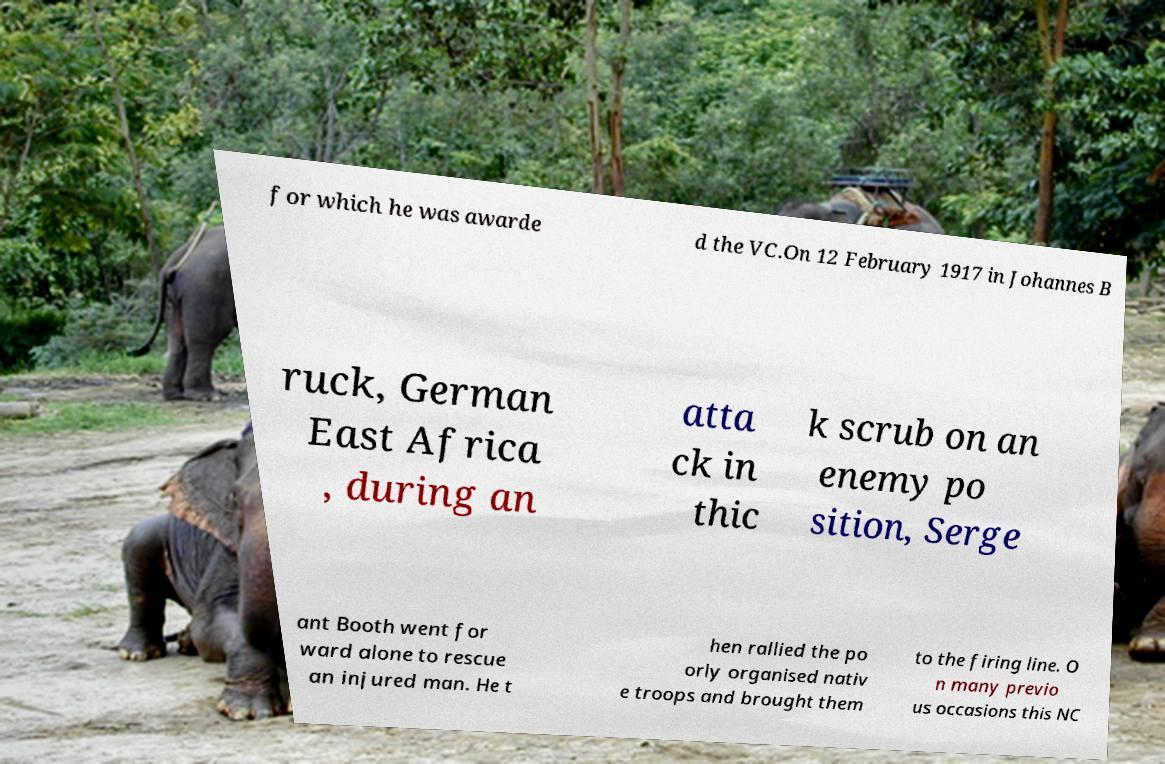Please identify and transcribe the text found in this image. for which he was awarde d the VC.On 12 February 1917 in Johannes B ruck, German East Africa , during an atta ck in thic k scrub on an enemy po sition, Serge ant Booth went for ward alone to rescue an injured man. He t hen rallied the po orly organised nativ e troops and brought them to the firing line. O n many previo us occasions this NC 